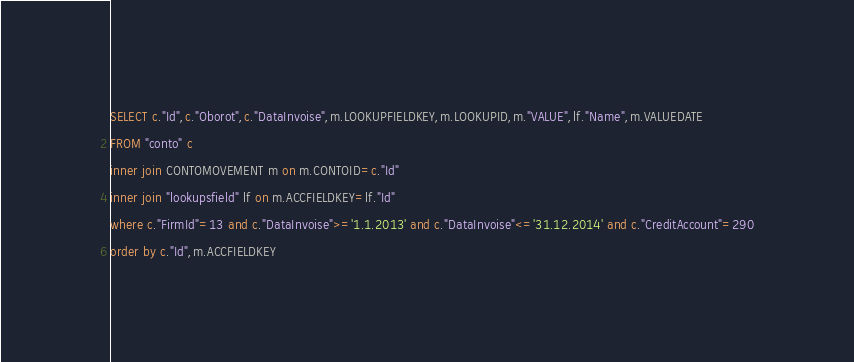<code> <loc_0><loc_0><loc_500><loc_500><_SQL_>SELECT c."Id",c."Oborot",c."DataInvoise",m.LOOKUPFIELDKEY,m.LOOKUPID,m."VALUE",lf."Name",m.VALUEDATE
FROM "conto" c 
inner join CONTOMOVEMENT m on m.CONTOID=c."Id"
inner join "lookupsfield" lf on m.ACCFIELDKEY=lf."Id"
where c."FirmId"=13 and c."DataInvoise">='1.1.2013' and c."DataInvoise"<='31.12.2014' and c."CreditAccount"=290
order by c."Id",m.ACCFIELDKEY</code> 